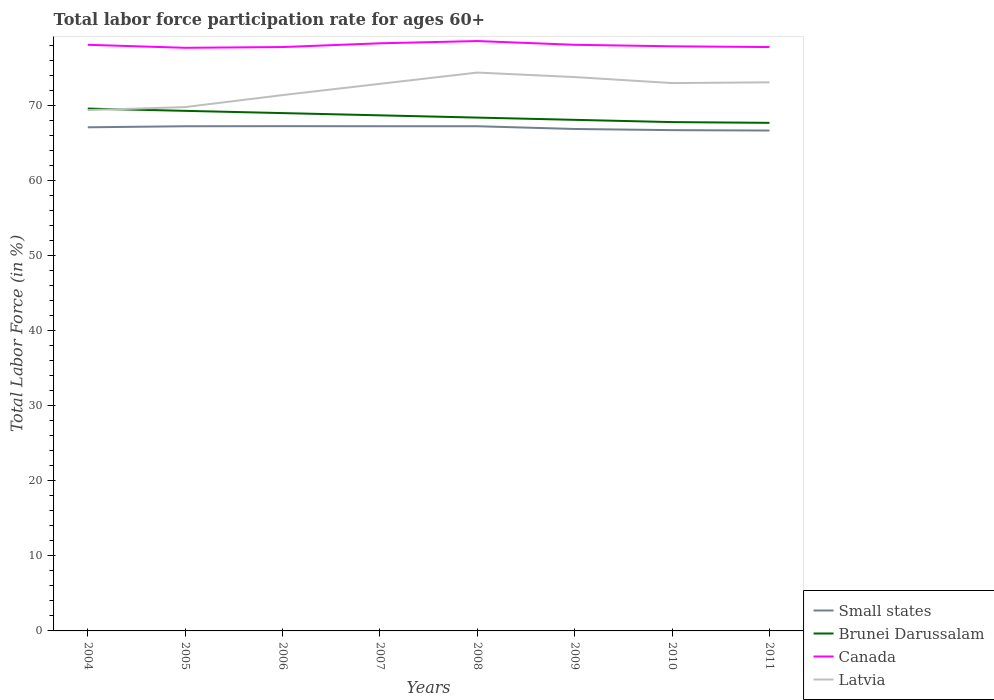How many different coloured lines are there?
Keep it short and to the point. 4. Does the line corresponding to Brunei Darussalam intersect with the line corresponding to Latvia?
Your response must be concise. Yes. Is the number of lines equal to the number of legend labels?
Your response must be concise. Yes. Across all years, what is the maximum labor force participation rate in Canada?
Offer a very short reply. 77.7. In which year was the labor force participation rate in Brunei Darussalam maximum?
Your answer should be compact. 2011. What is the total labor force participation rate in Canada in the graph?
Make the answer very short. 0.1. What is the difference between the highest and the second highest labor force participation rate in Latvia?
Your answer should be very brief. 5. What is the difference between the highest and the lowest labor force participation rate in Latvia?
Your answer should be compact. 5. Is the labor force participation rate in Small states strictly greater than the labor force participation rate in Latvia over the years?
Make the answer very short. Yes. How many lines are there?
Make the answer very short. 4. Are the values on the major ticks of Y-axis written in scientific E-notation?
Your answer should be compact. No. Does the graph contain grids?
Offer a very short reply. No. How many legend labels are there?
Give a very brief answer. 4. How are the legend labels stacked?
Your answer should be very brief. Vertical. What is the title of the graph?
Give a very brief answer. Total labor force participation rate for ages 60+. Does "Puerto Rico" appear as one of the legend labels in the graph?
Ensure brevity in your answer.  No. What is the label or title of the X-axis?
Your response must be concise. Years. What is the Total Labor Force (in %) in Small states in 2004?
Your answer should be very brief. 67.11. What is the Total Labor Force (in %) of Brunei Darussalam in 2004?
Offer a terse response. 69.6. What is the Total Labor Force (in %) of Canada in 2004?
Offer a terse response. 78.1. What is the Total Labor Force (in %) in Latvia in 2004?
Offer a terse response. 69.4. What is the Total Labor Force (in %) in Small states in 2005?
Provide a short and direct response. 67.25. What is the Total Labor Force (in %) in Brunei Darussalam in 2005?
Give a very brief answer. 69.3. What is the Total Labor Force (in %) of Canada in 2005?
Keep it short and to the point. 77.7. What is the Total Labor Force (in %) in Latvia in 2005?
Make the answer very short. 69.8. What is the Total Labor Force (in %) in Small states in 2006?
Your response must be concise. 67.26. What is the Total Labor Force (in %) in Brunei Darussalam in 2006?
Offer a very short reply. 69. What is the Total Labor Force (in %) of Canada in 2006?
Your answer should be compact. 77.8. What is the Total Labor Force (in %) in Latvia in 2006?
Give a very brief answer. 71.4. What is the Total Labor Force (in %) in Small states in 2007?
Provide a succinct answer. 67.25. What is the Total Labor Force (in %) in Brunei Darussalam in 2007?
Your answer should be compact. 68.7. What is the Total Labor Force (in %) of Canada in 2007?
Ensure brevity in your answer.  78.3. What is the Total Labor Force (in %) in Latvia in 2007?
Make the answer very short. 72.9. What is the Total Labor Force (in %) of Small states in 2008?
Keep it short and to the point. 67.25. What is the Total Labor Force (in %) in Brunei Darussalam in 2008?
Ensure brevity in your answer.  68.4. What is the Total Labor Force (in %) in Canada in 2008?
Your answer should be very brief. 78.6. What is the Total Labor Force (in %) of Latvia in 2008?
Your answer should be compact. 74.4. What is the Total Labor Force (in %) in Small states in 2009?
Offer a terse response. 66.88. What is the Total Labor Force (in %) in Brunei Darussalam in 2009?
Keep it short and to the point. 68.1. What is the Total Labor Force (in %) in Canada in 2009?
Provide a short and direct response. 78.1. What is the Total Labor Force (in %) in Latvia in 2009?
Give a very brief answer. 73.8. What is the Total Labor Force (in %) of Small states in 2010?
Make the answer very short. 66.73. What is the Total Labor Force (in %) of Brunei Darussalam in 2010?
Make the answer very short. 67.8. What is the Total Labor Force (in %) in Canada in 2010?
Make the answer very short. 77.9. What is the Total Labor Force (in %) of Small states in 2011?
Offer a very short reply. 66.68. What is the Total Labor Force (in %) in Brunei Darussalam in 2011?
Provide a short and direct response. 67.7. What is the Total Labor Force (in %) of Canada in 2011?
Make the answer very short. 77.8. What is the Total Labor Force (in %) of Latvia in 2011?
Keep it short and to the point. 73.1. Across all years, what is the maximum Total Labor Force (in %) in Small states?
Make the answer very short. 67.26. Across all years, what is the maximum Total Labor Force (in %) in Brunei Darussalam?
Your answer should be very brief. 69.6. Across all years, what is the maximum Total Labor Force (in %) of Canada?
Offer a terse response. 78.6. Across all years, what is the maximum Total Labor Force (in %) of Latvia?
Your response must be concise. 74.4. Across all years, what is the minimum Total Labor Force (in %) in Small states?
Keep it short and to the point. 66.68. Across all years, what is the minimum Total Labor Force (in %) of Brunei Darussalam?
Ensure brevity in your answer.  67.7. Across all years, what is the minimum Total Labor Force (in %) of Canada?
Ensure brevity in your answer.  77.7. Across all years, what is the minimum Total Labor Force (in %) of Latvia?
Ensure brevity in your answer.  69.4. What is the total Total Labor Force (in %) in Small states in the graph?
Provide a succinct answer. 536.4. What is the total Total Labor Force (in %) in Brunei Darussalam in the graph?
Your answer should be very brief. 548.6. What is the total Total Labor Force (in %) in Canada in the graph?
Provide a succinct answer. 624.3. What is the total Total Labor Force (in %) in Latvia in the graph?
Provide a short and direct response. 577.8. What is the difference between the Total Labor Force (in %) in Small states in 2004 and that in 2005?
Your response must be concise. -0.14. What is the difference between the Total Labor Force (in %) in Canada in 2004 and that in 2005?
Keep it short and to the point. 0.4. What is the difference between the Total Labor Force (in %) of Small states in 2004 and that in 2006?
Make the answer very short. -0.15. What is the difference between the Total Labor Force (in %) of Brunei Darussalam in 2004 and that in 2006?
Provide a short and direct response. 0.6. What is the difference between the Total Labor Force (in %) in Latvia in 2004 and that in 2006?
Make the answer very short. -2. What is the difference between the Total Labor Force (in %) of Small states in 2004 and that in 2007?
Keep it short and to the point. -0.14. What is the difference between the Total Labor Force (in %) of Canada in 2004 and that in 2007?
Provide a short and direct response. -0.2. What is the difference between the Total Labor Force (in %) of Small states in 2004 and that in 2008?
Provide a short and direct response. -0.14. What is the difference between the Total Labor Force (in %) of Latvia in 2004 and that in 2008?
Make the answer very short. -5. What is the difference between the Total Labor Force (in %) of Small states in 2004 and that in 2009?
Make the answer very short. 0.22. What is the difference between the Total Labor Force (in %) of Small states in 2004 and that in 2010?
Provide a short and direct response. 0.38. What is the difference between the Total Labor Force (in %) of Brunei Darussalam in 2004 and that in 2010?
Offer a very short reply. 1.8. What is the difference between the Total Labor Force (in %) in Canada in 2004 and that in 2010?
Your answer should be very brief. 0.2. What is the difference between the Total Labor Force (in %) of Latvia in 2004 and that in 2010?
Make the answer very short. -3.6. What is the difference between the Total Labor Force (in %) in Small states in 2004 and that in 2011?
Provide a succinct answer. 0.43. What is the difference between the Total Labor Force (in %) of Canada in 2004 and that in 2011?
Provide a short and direct response. 0.3. What is the difference between the Total Labor Force (in %) of Latvia in 2004 and that in 2011?
Make the answer very short. -3.7. What is the difference between the Total Labor Force (in %) in Small states in 2005 and that in 2006?
Your response must be concise. -0.01. What is the difference between the Total Labor Force (in %) in Brunei Darussalam in 2005 and that in 2006?
Your answer should be very brief. 0.3. What is the difference between the Total Labor Force (in %) in Canada in 2005 and that in 2006?
Offer a terse response. -0.1. What is the difference between the Total Labor Force (in %) in Small states in 2005 and that in 2007?
Keep it short and to the point. -0. What is the difference between the Total Labor Force (in %) of Brunei Darussalam in 2005 and that in 2007?
Keep it short and to the point. 0.6. What is the difference between the Total Labor Force (in %) of Small states in 2005 and that in 2008?
Make the answer very short. -0. What is the difference between the Total Labor Force (in %) of Brunei Darussalam in 2005 and that in 2008?
Make the answer very short. 0.9. What is the difference between the Total Labor Force (in %) in Canada in 2005 and that in 2008?
Provide a succinct answer. -0.9. What is the difference between the Total Labor Force (in %) of Small states in 2005 and that in 2009?
Offer a terse response. 0.36. What is the difference between the Total Labor Force (in %) of Small states in 2005 and that in 2010?
Your response must be concise. 0.52. What is the difference between the Total Labor Force (in %) in Brunei Darussalam in 2005 and that in 2010?
Provide a short and direct response. 1.5. What is the difference between the Total Labor Force (in %) in Canada in 2005 and that in 2010?
Ensure brevity in your answer.  -0.2. What is the difference between the Total Labor Force (in %) in Latvia in 2005 and that in 2010?
Make the answer very short. -3.2. What is the difference between the Total Labor Force (in %) of Small states in 2005 and that in 2011?
Offer a very short reply. 0.57. What is the difference between the Total Labor Force (in %) of Latvia in 2005 and that in 2011?
Your answer should be compact. -3.3. What is the difference between the Total Labor Force (in %) in Small states in 2006 and that in 2007?
Your answer should be compact. 0.01. What is the difference between the Total Labor Force (in %) of Small states in 2006 and that in 2008?
Provide a succinct answer. 0.01. What is the difference between the Total Labor Force (in %) of Brunei Darussalam in 2006 and that in 2008?
Give a very brief answer. 0.6. What is the difference between the Total Labor Force (in %) of Canada in 2006 and that in 2008?
Your response must be concise. -0.8. What is the difference between the Total Labor Force (in %) of Latvia in 2006 and that in 2008?
Make the answer very short. -3. What is the difference between the Total Labor Force (in %) of Small states in 2006 and that in 2009?
Ensure brevity in your answer.  0.38. What is the difference between the Total Labor Force (in %) in Brunei Darussalam in 2006 and that in 2009?
Offer a terse response. 0.9. What is the difference between the Total Labor Force (in %) in Small states in 2006 and that in 2010?
Provide a short and direct response. 0.53. What is the difference between the Total Labor Force (in %) of Brunei Darussalam in 2006 and that in 2010?
Provide a succinct answer. 1.2. What is the difference between the Total Labor Force (in %) of Canada in 2006 and that in 2010?
Your answer should be very brief. -0.1. What is the difference between the Total Labor Force (in %) of Small states in 2006 and that in 2011?
Offer a terse response. 0.58. What is the difference between the Total Labor Force (in %) in Brunei Darussalam in 2006 and that in 2011?
Your answer should be very brief. 1.3. What is the difference between the Total Labor Force (in %) of Canada in 2006 and that in 2011?
Your answer should be very brief. 0. What is the difference between the Total Labor Force (in %) in Brunei Darussalam in 2007 and that in 2008?
Give a very brief answer. 0.3. What is the difference between the Total Labor Force (in %) of Latvia in 2007 and that in 2008?
Your response must be concise. -1.5. What is the difference between the Total Labor Force (in %) of Small states in 2007 and that in 2009?
Offer a terse response. 0.37. What is the difference between the Total Labor Force (in %) in Brunei Darussalam in 2007 and that in 2009?
Make the answer very short. 0.6. What is the difference between the Total Labor Force (in %) in Latvia in 2007 and that in 2009?
Your answer should be compact. -0.9. What is the difference between the Total Labor Force (in %) of Small states in 2007 and that in 2010?
Provide a succinct answer. 0.52. What is the difference between the Total Labor Force (in %) in Brunei Darussalam in 2007 and that in 2010?
Offer a very short reply. 0.9. What is the difference between the Total Labor Force (in %) of Canada in 2007 and that in 2010?
Give a very brief answer. 0.4. What is the difference between the Total Labor Force (in %) in Small states in 2007 and that in 2011?
Ensure brevity in your answer.  0.57. What is the difference between the Total Labor Force (in %) in Brunei Darussalam in 2007 and that in 2011?
Give a very brief answer. 1. What is the difference between the Total Labor Force (in %) of Small states in 2008 and that in 2009?
Your answer should be compact. 0.37. What is the difference between the Total Labor Force (in %) in Latvia in 2008 and that in 2009?
Your answer should be very brief. 0.6. What is the difference between the Total Labor Force (in %) in Small states in 2008 and that in 2010?
Your answer should be compact. 0.52. What is the difference between the Total Labor Force (in %) of Canada in 2008 and that in 2010?
Your answer should be very brief. 0.7. What is the difference between the Total Labor Force (in %) of Small states in 2008 and that in 2011?
Keep it short and to the point. 0.57. What is the difference between the Total Labor Force (in %) of Brunei Darussalam in 2008 and that in 2011?
Give a very brief answer. 0.7. What is the difference between the Total Labor Force (in %) of Small states in 2009 and that in 2010?
Keep it short and to the point. 0.15. What is the difference between the Total Labor Force (in %) in Brunei Darussalam in 2009 and that in 2010?
Ensure brevity in your answer.  0.3. What is the difference between the Total Labor Force (in %) of Latvia in 2009 and that in 2010?
Your answer should be compact. 0.8. What is the difference between the Total Labor Force (in %) of Small states in 2009 and that in 2011?
Keep it short and to the point. 0.21. What is the difference between the Total Labor Force (in %) of Brunei Darussalam in 2009 and that in 2011?
Give a very brief answer. 0.4. What is the difference between the Total Labor Force (in %) in Canada in 2009 and that in 2011?
Ensure brevity in your answer.  0.3. What is the difference between the Total Labor Force (in %) in Small states in 2010 and that in 2011?
Keep it short and to the point. 0.05. What is the difference between the Total Labor Force (in %) of Latvia in 2010 and that in 2011?
Keep it short and to the point. -0.1. What is the difference between the Total Labor Force (in %) of Small states in 2004 and the Total Labor Force (in %) of Brunei Darussalam in 2005?
Ensure brevity in your answer.  -2.19. What is the difference between the Total Labor Force (in %) of Small states in 2004 and the Total Labor Force (in %) of Canada in 2005?
Provide a short and direct response. -10.59. What is the difference between the Total Labor Force (in %) in Small states in 2004 and the Total Labor Force (in %) in Latvia in 2005?
Ensure brevity in your answer.  -2.69. What is the difference between the Total Labor Force (in %) in Brunei Darussalam in 2004 and the Total Labor Force (in %) in Latvia in 2005?
Provide a succinct answer. -0.2. What is the difference between the Total Labor Force (in %) in Canada in 2004 and the Total Labor Force (in %) in Latvia in 2005?
Ensure brevity in your answer.  8.3. What is the difference between the Total Labor Force (in %) of Small states in 2004 and the Total Labor Force (in %) of Brunei Darussalam in 2006?
Ensure brevity in your answer.  -1.89. What is the difference between the Total Labor Force (in %) in Small states in 2004 and the Total Labor Force (in %) in Canada in 2006?
Ensure brevity in your answer.  -10.69. What is the difference between the Total Labor Force (in %) of Small states in 2004 and the Total Labor Force (in %) of Latvia in 2006?
Keep it short and to the point. -4.29. What is the difference between the Total Labor Force (in %) in Canada in 2004 and the Total Labor Force (in %) in Latvia in 2006?
Your answer should be compact. 6.7. What is the difference between the Total Labor Force (in %) in Small states in 2004 and the Total Labor Force (in %) in Brunei Darussalam in 2007?
Your response must be concise. -1.59. What is the difference between the Total Labor Force (in %) of Small states in 2004 and the Total Labor Force (in %) of Canada in 2007?
Give a very brief answer. -11.19. What is the difference between the Total Labor Force (in %) of Small states in 2004 and the Total Labor Force (in %) of Latvia in 2007?
Offer a very short reply. -5.79. What is the difference between the Total Labor Force (in %) of Canada in 2004 and the Total Labor Force (in %) of Latvia in 2007?
Keep it short and to the point. 5.2. What is the difference between the Total Labor Force (in %) of Small states in 2004 and the Total Labor Force (in %) of Brunei Darussalam in 2008?
Provide a short and direct response. -1.29. What is the difference between the Total Labor Force (in %) of Small states in 2004 and the Total Labor Force (in %) of Canada in 2008?
Provide a succinct answer. -11.49. What is the difference between the Total Labor Force (in %) in Small states in 2004 and the Total Labor Force (in %) in Latvia in 2008?
Provide a short and direct response. -7.29. What is the difference between the Total Labor Force (in %) in Small states in 2004 and the Total Labor Force (in %) in Brunei Darussalam in 2009?
Keep it short and to the point. -0.99. What is the difference between the Total Labor Force (in %) of Small states in 2004 and the Total Labor Force (in %) of Canada in 2009?
Keep it short and to the point. -10.99. What is the difference between the Total Labor Force (in %) in Small states in 2004 and the Total Labor Force (in %) in Latvia in 2009?
Provide a succinct answer. -6.69. What is the difference between the Total Labor Force (in %) in Brunei Darussalam in 2004 and the Total Labor Force (in %) in Canada in 2009?
Make the answer very short. -8.5. What is the difference between the Total Labor Force (in %) in Brunei Darussalam in 2004 and the Total Labor Force (in %) in Latvia in 2009?
Your answer should be very brief. -4.2. What is the difference between the Total Labor Force (in %) of Small states in 2004 and the Total Labor Force (in %) of Brunei Darussalam in 2010?
Your answer should be compact. -0.69. What is the difference between the Total Labor Force (in %) in Small states in 2004 and the Total Labor Force (in %) in Canada in 2010?
Provide a succinct answer. -10.79. What is the difference between the Total Labor Force (in %) of Small states in 2004 and the Total Labor Force (in %) of Latvia in 2010?
Your response must be concise. -5.89. What is the difference between the Total Labor Force (in %) of Brunei Darussalam in 2004 and the Total Labor Force (in %) of Canada in 2010?
Offer a terse response. -8.3. What is the difference between the Total Labor Force (in %) of Brunei Darussalam in 2004 and the Total Labor Force (in %) of Latvia in 2010?
Your response must be concise. -3.4. What is the difference between the Total Labor Force (in %) in Small states in 2004 and the Total Labor Force (in %) in Brunei Darussalam in 2011?
Keep it short and to the point. -0.59. What is the difference between the Total Labor Force (in %) of Small states in 2004 and the Total Labor Force (in %) of Canada in 2011?
Keep it short and to the point. -10.69. What is the difference between the Total Labor Force (in %) of Small states in 2004 and the Total Labor Force (in %) of Latvia in 2011?
Ensure brevity in your answer.  -5.99. What is the difference between the Total Labor Force (in %) of Brunei Darussalam in 2004 and the Total Labor Force (in %) of Canada in 2011?
Your answer should be compact. -8.2. What is the difference between the Total Labor Force (in %) of Small states in 2005 and the Total Labor Force (in %) of Brunei Darussalam in 2006?
Ensure brevity in your answer.  -1.75. What is the difference between the Total Labor Force (in %) in Small states in 2005 and the Total Labor Force (in %) in Canada in 2006?
Your answer should be very brief. -10.55. What is the difference between the Total Labor Force (in %) in Small states in 2005 and the Total Labor Force (in %) in Latvia in 2006?
Your answer should be compact. -4.15. What is the difference between the Total Labor Force (in %) of Brunei Darussalam in 2005 and the Total Labor Force (in %) of Canada in 2006?
Ensure brevity in your answer.  -8.5. What is the difference between the Total Labor Force (in %) of Small states in 2005 and the Total Labor Force (in %) of Brunei Darussalam in 2007?
Offer a very short reply. -1.45. What is the difference between the Total Labor Force (in %) of Small states in 2005 and the Total Labor Force (in %) of Canada in 2007?
Make the answer very short. -11.05. What is the difference between the Total Labor Force (in %) of Small states in 2005 and the Total Labor Force (in %) of Latvia in 2007?
Your response must be concise. -5.65. What is the difference between the Total Labor Force (in %) in Brunei Darussalam in 2005 and the Total Labor Force (in %) in Latvia in 2007?
Ensure brevity in your answer.  -3.6. What is the difference between the Total Labor Force (in %) in Small states in 2005 and the Total Labor Force (in %) in Brunei Darussalam in 2008?
Keep it short and to the point. -1.15. What is the difference between the Total Labor Force (in %) of Small states in 2005 and the Total Labor Force (in %) of Canada in 2008?
Make the answer very short. -11.35. What is the difference between the Total Labor Force (in %) of Small states in 2005 and the Total Labor Force (in %) of Latvia in 2008?
Ensure brevity in your answer.  -7.15. What is the difference between the Total Labor Force (in %) in Brunei Darussalam in 2005 and the Total Labor Force (in %) in Canada in 2008?
Your answer should be very brief. -9.3. What is the difference between the Total Labor Force (in %) in Small states in 2005 and the Total Labor Force (in %) in Brunei Darussalam in 2009?
Offer a terse response. -0.85. What is the difference between the Total Labor Force (in %) of Small states in 2005 and the Total Labor Force (in %) of Canada in 2009?
Make the answer very short. -10.85. What is the difference between the Total Labor Force (in %) in Small states in 2005 and the Total Labor Force (in %) in Latvia in 2009?
Your answer should be very brief. -6.55. What is the difference between the Total Labor Force (in %) of Small states in 2005 and the Total Labor Force (in %) of Brunei Darussalam in 2010?
Make the answer very short. -0.55. What is the difference between the Total Labor Force (in %) of Small states in 2005 and the Total Labor Force (in %) of Canada in 2010?
Offer a terse response. -10.65. What is the difference between the Total Labor Force (in %) in Small states in 2005 and the Total Labor Force (in %) in Latvia in 2010?
Keep it short and to the point. -5.75. What is the difference between the Total Labor Force (in %) of Brunei Darussalam in 2005 and the Total Labor Force (in %) of Canada in 2010?
Ensure brevity in your answer.  -8.6. What is the difference between the Total Labor Force (in %) of Brunei Darussalam in 2005 and the Total Labor Force (in %) of Latvia in 2010?
Provide a succinct answer. -3.7. What is the difference between the Total Labor Force (in %) in Small states in 2005 and the Total Labor Force (in %) in Brunei Darussalam in 2011?
Make the answer very short. -0.45. What is the difference between the Total Labor Force (in %) of Small states in 2005 and the Total Labor Force (in %) of Canada in 2011?
Offer a very short reply. -10.55. What is the difference between the Total Labor Force (in %) in Small states in 2005 and the Total Labor Force (in %) in Latvia in 2011?
Make the answer very short. -5.85. What is the difference between the Total Labor Force (in %) in Brunei Darussalam in 2005 and the Total Labor Force (in %) in Canada in 2011?
Ensure brevity in your answer.  -8.5. What is the difference between the Total Labor Force (in %) of Small states in 2006 and the Total Labor Force (in %) of Brunei Darussalam in 2007?
Make the answer very short. -1.44. What is the difference between the Total Labor Force (in %) of Small states in 2006 and the Total Labor Force (in %) of Canada in 2007?
Your answer should be very brief. -11.04. What is the difference between the Total Labor Force (in %) in Small states in 2006 and the Total Labor Force (in %) in Latvia in 2007?
Provide a succinct answer. -5.64. What is the difference between the Total Labor Force (in %) of Brunei Darussalam in 2006 and the Total Labor Force (in %) of Canada in 2007?
Keep it short and to the point. -9.3. What is the difference between the Total Labor Force (in %) of Brunei Darussalam in 2006 and the Total Labor Force (in %) of Latvia in 2007?
Your answer should be compact. -3.9. What is the difference between the Total Labor Force (in %) in Canada in 2006 and the Total Labor Force (in %) in Latvia in 2007?
Provide a succinct answer. 4.9. What is the difference between the Total Labor Force (in %) of Small states in 2006 and the Total Labor Force (in %) of Brunei Darussalam in 2008?
Ensure brevity in your answer.  -1.14. What is the difference between the Total Labor Force (in %) of Small states in 2006 and the Total Labor Force (in %) of Canada in 2008?
Offer a terse response. -11.34. What is the difference between the Total Labor Force (in %) in Small states in 2006 and the Total Labor Force (in %) in Latvia in 2008?
Give a very brief answer. -7.14. What is the difference between the Total Labor Force (in %) of Canada in 2006 and the Total Labor Force (in %) of Latvia in 2008?
Keep it short and to the point. 3.4. What is the difference between the Total Labor Force (in %) in Small states in 2006 and the Total Labor Force (in %) in Brunei Darussalam in 2009?
Keep it short and to the point. -0.84. What is the difference between the Total Labor Force (in %) in Small states in 2006 and the Total Labor Force (in %) in Canada in 2009?
Offer a very short reply. -10.84. What is the difference between the Total Labor Force (in %) of Small states in 2006 and the Total Labor Force (in %) of Latvia in 2009?
Provide a short and direct response. -6.54. What is the difference between the Total Labor Force (in %) of Brunei Darussalam in 2006 and the Total Labor Force (in %) of Latvia in 2009?
Keep it short and to the point. -4.8. What is the difference between the Total Labor Force (in %) of Canada in 2006 and the Total Labor Force (in %) of Latvia in 2009?
Your response must be concise. 4. What is the difference between the Total Labor Force (in %) in Small states in 2006 and the Total Labor Force (in %) in Brunei Darussalam in 2010?
Make the answer very short. -0.54. What is the difference between the Total Labor Force (in %) in Small states in 2006 and the Total Labor Force (in %) in Canada in 2010?
Make the answer very short. -10.64. What is the difference between the Total Labor Force (in %) of Small states in 2006 and the Total Labor Force (in %) of Latvia in 2010?
Offer a very short reply. -5.74. What is the difference between the Total Labor Force (in %) of Brunei Darussalam in 2006 and the Total Labor Force (in %) of Latvia in 2010?
Offer a very short reply. -4. What is the difference between the Total Labor Force (in %) in Small states in 2006 and the Total Labor Force (in %) in Brunei Darussalam in 2011?
Offer a terse response. -0.44. What is the difference between the Total Labor Force (in %) of Small states in 2006 and the Total Labor Force (in %) of Canada in 2011?
Provide a short and direct response. -10.54. What is the difference between the Total Labor Force (in %) of Small states in 2006 and the Total Labor Force (in %) of Latvia in 2011?
Give a very brief answer. -5.84. What is the difference between the Total Labor Force (in %) in Brunei Darussalam in 2006 and the Total Labor Force (in %) in Canada in 2011?
Make the answer very short. -8.8. What is the difference between the Total Labor Force (in %) in Brunei Darussalam in 2006 and the Total Labor Force (in %) in Latvia in 2011?
Give a very brief answer. -4.1. What is the difference between the Total Labor Force (in %) in Canada in 2006 and the Total Labor Force (in %) in Latvia in 2011?
Your answer should be very brief. 4.7. What is the difference between the Total Labor Force (in %) of Small states in 2007 and the Total Labor Force (in %) of Brunei Darussalam in 2008?
Offer a terse response. -1.15. What is the difference between the Total Labor Force (in %) of Small states in 2007 and the Total Labor Force (in %) of Canada in 2008?
Provide a short and direct response. -11.35. What is the difference between the Total Labor Force (in %) of Small states in 2007 and the Total Labor Force (in %) of Latvia in 2008?
Your response must be concise. -7.15. What is the difference between the Total Labor Force (in %) in Brunei Darussalam in 2007 and the Total Labor Force (in %) in Canada in 2008?
Keep it short and to the point. -9.9. What is the difference between the Total Labor Force (in %) of Small states in 2007 and the Total Labor Force (in %) of Brunei Darussalam in 2009?
Make the answer very short. -0.85. What is the difference between the Total Labor Force (in %) in Small states in 2007 and the Total Labor Force (in %) in Canada in 2009?
Make the answer very short. -10.85. What is the difference between the Total Labor Force (in %) of Small states in 2007 and the Total Labor Force (in %) of Latvia in 2009?
Provide a short and direct response. -6.55. What is the difference between the Total Labor Force (in %) in Brunei Darussalam in 2007 and the Total Labor Force (in %) in Latvia in 2009?
Keep it short and to the point. -5.1. What is the difference between the Total Labor Force (in %) of Canada in 2007 and the Total Labor Force (in %) of Latvia in 2009?
Provide a short and direct response. 4.5. What is the difference between the Total Labor Force (in %) of Small states in 2007 and the Total Labor Force (in %) of Brunei Darussalam in 2010?
Your answer should be very brief. -0.55. What is the difference between the Total Labor Force (in %) of Small states in 2007 and the Total Labor Force (in %) of Canada in 2010?
Provide a succinct answer. -10.65. What is the difference between the Total Labor Force (in %) of Small states in 2007 and the Total Labor Force (in %) of Latvia in 2010?
Provide a short and direct response. -5.75. What is the difference between the Total Labor Force (in %) of Canada in 2007 and the Total Labor Force (in %) of Latvia in 2010?
Keep it short and to the point. 5.3. What is the difference between the Total Labor Force (in %) in Small states in 2007 and the Total Labor Force (in %) in Brunei Darussalam in 2011?
Make the answer very short. -0.45. What is the difference between the Total Labor Force (in %) in Small states in 2007 and the Total Labor Force (in %) in Canada in 2011?
Make the answer very short. -10.55. What is the difference between the Total Labor Force (in %) in Small states in 2007 and the Total Labor Force (in %) in Latvia in 2011?
Provide a short and direct response. -5.85. What is the difference between the Total Labor Force (in %) in Brunei Darussalam in 2007 and the Total Labor Force (in %) in Canada in 2011?
Offer a terse response. -9.1. What is the difference between the Total Labor Force (in %) of Brunei Darussalam in 2007 and the Total Labor Force (in %) of Latvia in 2011?
Make the answer very short. -4.4. What is the difference between the Total Labor Force (in %) of Canada in 2007 and the Total Labor Force (in %) of Latvia in 2011?
Provide a succinct answer. 5.2. What is the difference between the Total Labor Force (in %) in Small states in 2008 and the Total Labor Force (in %) in Brunei Darussalam in 2009?
Provide a short and direct response. -0.85. What is the difference between the Total Labor Force (in %) of Small states in 2008 and the Total Labor Force (in %) of Canada in 2009?
Your answer should be very brief. -10.85. What is the difference between the Total Labor Force (in %) in Small states in 2008 and the Total Labor Force (in %) in Latvia in 2009?
Provide a short and direct response. -6.55. What is the difference between the Total Labor Force (in %) in Brunei Darussalam in 2008 and the Total Labor Force (in %) in Canada in 2009?
Offer a very short reply. -9.7. What is the difference between the Total Labor Force (in %) of Canada in 2008 and the Total Labor Force (in %) of Latvia in 2009?
Your answer should be very brief. 4.8. What is the difference between the Total Labor Force (in %) of Small states in 2008 and the Total Labor Force (in %) of Brunei Darussalam in 2010?
Ensure brevity in your answer.  -0.55. What is the difference between the Total Labor Force (in %) in Small states in 2008 and the Total Labor Force (in %) in Canada in 2010?
Provide a succinct answer. -10.65. What is the difference between the Total Labor Force (in %) in Small states in 2008 and the Total Labor Force (in %) in Latvia in 2010?
Your response must be concise. -5.75. What is the difference between the Total Labor Force (in %) of Brunei Darussalam in 2008 and the Total Labor Force (in %) of Latvia in 2010?
Offer a terse response. -4.6. What is the difference between the Total Labor Force (in %) of Small states in 2008 and the Total Labor Force (in %) of Brunei Darussalam in 2011?
Offer a very short reply. -0.45. What is the difference between the Total Labor Force (in %) of Small states in 2008 and the Total Labor Force (in %) of Canada in 2011?
Keep it short and to the point. -10.55. What is the difference between the Total Labor Force (in %) in Small states in 2008 and the Total Labor Force (in %) in Latvia in 2011?
Offer a very short reply. -5.85. What is the difference between the Total Labor Force (in %) in Canada in 2008 and the Total Labor Force (in %) in Latvia in 2011?
Your response must be concise. 5.5. What is the difference between the Total Labor Force (in %) of Small states in 2009 and the Total Labor Force (in %) of Brunei Darussalam in 2010?
Ensure brevity in your answer.  -0.92. What is the difference between the Total Labor Force (in %) of Small states in 2009 and the Total Labor Force (in %) of Canada in 2010?
Give a very brief answer. -11.02. What is the difference between the Total Labor Force (in %) in Small states in 2009 and the Total Labor Force (in %) in Latvia in 2010?
Your response must be concise. -6.12. What is the difference between the Total Labor Force (in %) of Canada in 2009 and the Total Labor Force (in %) of Latvia in 2010?
Your response must be concise. 5.1. What is the difference between the Total Labor Force (in %) of Small states in 2009 and the Total Labor Force (in %) of Brunei Darussalam in 2011?
Offer a terse response. -0.82. What is the difference between the Total Labor Force (in %) of Small states in 2009 and the Total Labor Force (in %) of Canada in 2011?
Ensure brevity in your answer.  -10.92. What is the difference between the Total Labor Force (in %) in Small states in 2009 and the Total Labor Force (in %) in Latvia in 2011?
Ensure brevity in your answer.  -6.22. What is the difference between the Total Labor Force (in %) in Canada in 2009 and the Total Labor Force (in %) in Latvia in 2011?
Make the answer very short. 5. What is the difference between the Total Labor Force (in %) of Small states in 2010 and the Total Labor Force (in %) of Brunei Darussalam in 2011?
Your answer should be very brief. -0.97. What is the difference between the Total Labor Force (in %) in Small states in 2010 and the Total Labor Force (in %) in Canada in 2011?
Your answer should be very brief. -11.07. What is the difference between the Total Labor Force (in %) of Small states in 2010 and the Total Labor Force (in %) of Latvia in 2011?
Keep it short and to the point. -6.37. What is the difference between the Total Labor Force (in %) in Brunei Darussalam in 2010 and the Total Labor Force (in %) in Latvia in 2011?
Provide a short and direct response. -5.3. What is the difference between the Total Labor Force (in %) in Canada in 2010 and the Total Labor Force (in %) in Latvia in 2011?
Keep it short and to the point. 4.8. What is the average Total Labor Force (in %) of Small states per year?
Keep it short and to the point. 67.05. What is the average Total Labor Force (in %) of Brunei Darussalam per year?
Ensure brevity in your answer.  68.58. What is the average Total Labor Force (in %) of Canada per year?
Your answer should be very brief. 78.04. What is the average Total Labor Force (in %) of Latvia per year?
Offer a terse response. 72.22. In the year 2004, what is the difference between the Total Labor Force (in %) in Small states and Total Labor Force (in %) in Brunei Darussalam?
Provide a short and direct response. -2.49. In the year 2004, what is the difference between the Total Labor Force (in %) in Small states and Total Labor Force (in %) in Canada?
Your response must be concise. -10.99. In the year 2004, what is the difference between the Total Labor Force (in %) of Small states and Total Labor Force (in %) of Latvia?
Ensure brevity in your answer.  -2.29. In the year 2004, what is the difference between the Total Labor Force (in %) of Brunei Darussalam and Total Labor Force (in %) of Canada?
Your answer should be compact. -8.5. In the year 2004, what is the difference between the Total Labor Force (in %) of Brunei Darussalam and Total Labor Force (in %) of Latvia?
Your response must be concise. 0.2. In the year 2005, what is the difference between the Total Labor Force (in %) of Small states and Total Labor Force (in %) of Brunei Darussalam?
Your answer should be very brief. -2.05. In the year 2005, what is the difference between the Total Labor Force (in %) in Small states and Total Labor Force (in %) in Canada?
Provide a short and direct response. -10.45. In the year 2005, what is the difference between the Total Labor Force (in %) in Small states and Total Labor Force (in %) in Latvia?
Provide a short and direct response. -2.55. In the year 2006, what is the difference between the Total Labor Force (in %) in Small states and Total Labor Force (in %) in Brunei Darussalam?
Ensure brevity in your answer.  -1.74. In the year 2006, what is the difference between the Total Labor Force (in %) of Small states and Total Labor Force (in %) of Canada?
Provide a succinct answer. -10.54. In the year 2006, what is the difference between the Total Labor Force (in %) in Small states and Total Labor Force (in %) in Latvia?
Your answer should be compact. -4.14. In the year 2006, what is the difference between the Total Labor Force (in %) in Brunei Darussalam and Total Labor Force (in %) in Canada?
Your answer should be compact. -8.8. In the year 2006, what is the difference between the Total Labor Force (in %) in Canada and Total Labor Force (in %) in Latvia?
Keep it short and to the point. 6.4. In the year 2007, what is the difference between the Total Labor Force (in %) of Small states and Total Labor Force (in %) of Brunei Darussalam?
Your answer should be very brief. -1.45. In the year 2007, what is the difference between the Total Labor Force (in %) in Small states and Total Labor Force (in %) in Canada?
Your answer should be very brief. -11.05. In the year 2007, what is the difference between the Total Labor Force (in %) of Small states and Total Labor Force (in %) of Latvia?
Ensure brevity in your answer.  -5.65. In the year 2007, what is the difference between the Total Labor Force (in %) of Canada and Total Labor Force (in %) of Latvia?
Ensure brevity in your answer.  5.4. In the year 2008, what is the difference between the Total Labor Force (in %) of Small states and Total Labor Force (in %) of Brunei Darussalam?
Your response must be concise. -1.15. In the year 2008, what is the difference between the Total Labor Force (in %) in Small states and Total Labor Force (in %) in Canada?
Offer a very short reply. -11.35. In the year 2008, what is the difference between the Total Labor Force (in %) in Small states and Total Labor Force (in %) in Latvia?
Your answer should be compact. -7.15. In the year 2008, what is the difference between the Total Labor Force (in %) in Brunei Darussalam and Total Labor Force (in %) in Canada?
Provide a succinct answer. -10.2. In the year 2009, what is the difference between the Total Labor Force (in %) in Small states and Total Labor Force (in %) in Brunei Darussalam?
Your response must be concise. -1.22. In the year 2009, what is the difference between the Total Labor Force (in %) of Small states and Total Labor Force (in %) of Canada?
Ensure brevity in your answer.  -11.22. In the year 2009, what is the difference between the Total Labor Force (in %) in Small states and Total Labor Force (in %) in Latvia?
Your answer should be compact. -6.92. In the year 2009, what is the difference between the Total Labor Force (in %) of Brunei Darussalam and Total Labor Force (in %) of Canada?
Your answer should be compact. -10. In the year 2009, what is the difference between the Total Labor Force (in %) in Canada and Total Labor Force (in %) in Latvia?
Provide a short and direct response. 4.3. In the year 2010, what is the difference between the Total Labor Force (in %) in Small states and Total Labor Force (in %) in Brunei Darussalam?
Give a very brief answer. -1.07. In the year 2010, what is the difference between the Total Labor Force (in %) of Small states and Total Labor Force (in %) of Canada?
Your answer should be very brief. -11.17. In the year 2010, what is the difference between the Total Labor Force (in %) of Small states and Total Labor Force (in %) of Latvia?
Your answer should be compact. -6.27. In the year 2010, what is the difference between the Total Labor Force (in %) of Brunei Darussalam and Total Labor Force (in %) of Latvia?
Keep it short and to the point. -5.2. In the year 2011, what is the difference between the Total Labor Force (in %) of Small states and Total Labor Force (in %) of Brunei Darussalam?
Your response must be concise. -1.02. In the year 2011, what is the difference between the Total Labor Force (in %) of Small states and Total Labor Force (in %) of Canada?
Offer a terse response. -11.12. In the year 2011, what is the difference between the Total Labor Force (in %) in Small states and Total Labor Force (in %) in Latvia?
Make the answer very short. -6.42. In the year 2011, what is the difference between the Total Labor Force (in %) of Brunei Darussalam and Total Labor Force (in %) of Canada?
Your answer should be compact. -10.1. In the year 2011, what is the difference between the Total Labor Force (in %) in Brunei Darussalam and Total Labor Force (in %) in Latvia?
Ensure brevity in your answer.  -5.4. In the year 2011, what is the difference between the Total Labor Force (in %) in Canada and Total Labor Force (in %) in Latvia?
Offer a very short reply. 4.7. What is the ratio of the Total Labor Force (in %) of Brunei Darussalam in 2004 to that in 2005?
Give a very brief answer. 1. What is the ratio of the Total Labor Force (in %) of Canada in 2004 to that in 2005?
Ensure brevity in your answer.  1.01. What is the ratio of the Total Labor Force (in %) of Small states in 2004 to that in 2006?
Your answer should be very brief. 1. What is the ratio of the Total Labor Force (in %) in Brunei Darussalam in 2004 to that in 2006?
Make the answer very short. 1.01. What is the ratio of the Total Labor Force (in %) of Brunei Darussalam in 2004 to that in 2007?
Offer a terse response. 1.01. What is the ratio of the Total Labor Force (in %) in Brunei Darussalam in 2004 to that in 2008?
Your answer should be very brief. 1.02. What is the ratio of the Total Labor Force (in %) of Canada in 2004 to that in 2008?
Your response must be concise. 0.99. What is the ratio of the Total Labor Force (in %) of Latvia in 2004 to that in 2008?
Make the answer very short. 0.93. What is the ratio of the Total Labor Force (in %) of Small states in 2004 to that in 2009?
Your response must be concise. 1. What is the ratio of the Total Labor Force (in %) of Latvia in 2004 to that in 2009?
Provide a short and direct response. 0.94. What is the ratio of the Total Labor Force (in %) of Brunei Darussalam in 2004 to that in 2010?
Offer a terse response. 1.03. What is the ratio of the Total Labor Force (in %) of Canada in 2004 to that in 2010?
Give a very brief answer. 1. What is the ratio of the Total Labor Force (in %) of Latvia in 2004 to that in 2010?
Provide a short and direct response. 0.95. What is the ratio of the Total Labor Force (in %) of Small states in 2004 to that in 2011?
Ensure brevity in your answer.  1.01. What is the ratio of the Total Labor Force (in %) of Brunei Darussalam in 2004 to that in 2011?
Offer a terse response. 1.03. What is the ratio of the Total Labor Force (in %) of Latvia in 2004 to that in 2011?
Give a very brief answer. 0.95. What is the ratio of the Total Labor Force (in %) of Brunei Darussalam in 2005 to that in 2006?
Keep it short and to the point. 1. What is the ratio of the Total Labor Force (in %) of Canada in 2005 to that in 2006?
Offer a terse response. 1. What is the ratio of the Total Labor Force (in %) in Latvia in 2005 to that in 2006?
Provide a short and direct response. 0.98. What is the ratio of the Total Labor Force (in %) in Brunei Darussalam in 2005 to that in 2007?
Offer a very short reply. 1.01. What is the ratio of the Total Labor Force (in %) in Latvia in 2005 to that in 2007?
Your answer should be compact. 0.96. What is the ratio of the Total Labor Force (in %) in Small states in 2005 to that in 2008?
Your answer should be very brief. 1. What is the ratio of the Total Labor Force (in %) of Brunei Darussalam in 2005 to that in 2008?
Your answer should be very brief. 1.01. What is the ratio of the Total Labor Force (in %) of Canada in 2005 to that in 2008?
Your answer should be very brief. 0.99. What is the ratio of the Total Labor Force (in %) in Latvia in 2005 to that in 2008?
Your answer should be compact. 0.94. What is the ratio of the Total Labor Force (in %) of Small states in 2005 to that in 2009?
Ensure brevity in your answer.  1.01. What is the ratio of the Total Labor Force (in %) of Brunei Darussalam in 2005 to that in 2009?
Give a very brief answer. 1.02. What is the ratio of the Total Labor Force (in %) in Latvia in 2005 to that in 2009?
Keep it short and to the point. 0.95. What is the ratio of the Total Labor Force (in %) of Brunei Darussalam in 2005 to that in 2010?
Offer a very short reply. 1.02. What is the ratio of the Total Labor Force (in %) in Canada in 2005 to that in 2010?
Your answer should be compact. 1. What is the ratio of the Total Labor Force (in %) in Latvia in 2005 to that in 2010?
Ensure brevity in your answer.  0.96. What is the ratio of the Total Labor Force (in %) in Small states in 2005 to that in 2011?
Provide a succinct answer. 1.01. What is the ratio of the Total Labor Force (in %) in Brunei Darussalam in 2005 to that in 2011?
Give a very brief answer. 1.02. What is the ratio of the Total Labor Force (in %) of Canada in 2005 to that in 2011?
Your answer should be compact. 1. What is the ratio of the Total Labor Force (in %) of Latvia in 2005 to that in 2011?
Keep it short and to the point. 0.95. What is the ratio of the Total Labor Force (in %) in Small states in 2006 to that in 2007?
Provide a succinct answer. 1. What is the ratio of the Total Labor Force (in %) of Canada in 2006 to that in 2007?
Ensure brevity in your answer.  0.99. What is the ratio of the Total Labor Force (in %) in Latvia in 2006 to that in 2007?
Keep it short and to the point. 0.98. What is the ratio of the Total Labor Force (in %) in Brunei Darussalam in 2006 to that in 2008?
Your answer should be very brief. 1.01. What is the ratio of the Total Labor Force (in %) of Latvia in 2006 to that in 2008?
Ensure brevity in your answer.  0.96. What is the ratio of the Total Labor Force (in %) in Small states in 2006 to that in 2009?
Provide a succinct answer. 1.01. What is the ratio of the Total Labor Force (in %) of Brunei Darussalam in 2006 to that in 2009?
Offer a very short reply. 1.01. What is the ratio of the Total Labor Force (in %) of Latvia in 2006 to that in 2009?
Provide a short and direct response. 0.97. What is the ratio of the Total Labor Force (in %) of Small states in 2006 to that in 2010?
Offer a terse response. 1.01. What is the ratio of the Total Labor Force (in %) in Brunei Darussalam in 2006 to that in 2010?
Offer a terse response. 1.02. What is the ratio of the Total Labor Force (in %) in Latvia in 2006 to that in 2010?
Give a very brief answer. 0.98. What is the ratio of the Total Labor Force (in %) of Small states in 2006 to that in 2011?
Provide a succinct answer. 1.01. What is the ratio of the Total Labor Force (in %) in Brunei Darussalam in 2006 to that in 2011?
Your response must be concise. 1.02. What is the ratio of the Total Labor Force (in %) of Canada in 2006 to that in 2011?
Your response must be concise. 1. What is the ratio of the Total Labor Force (in %) of Latvia in 2006 to that in 2011?
Offer a very short reply. 0.98. What is the ratio of the Total Labor Force (in %) of Brunei Darussalam in 2007 to that in 2008?
Provide a succinct answer. 1. What is the ratio of the Total Labor Force (in %) of Latvia in 2007 to that in 2008?
Make the answer very short. 0.98. What is the ratio of the Total Labor Force (in %) in Small states in 2007 to that in 2009?
Give a very brief answer. 1.01. What is the ratio of the Total Labor Force (in %) of Brunei Darussalam in 2007 to that in 2009?
Provide a succinct answer. 1.01. What is the ratio of the Total Labor Force (in %) of Latvia in 2007 to that in 2009?
Provide a short and direct response. 0.99. What is the ratio of the Total Labor Force (in %) in Small states in 2007 to that in 2010?
Your answer should be very brief. 1.01. What is the ratio of the Total Labor Force (in %) in Brunei Darussalam in 2007 to that in 2010?
Provide a short and direct response. 1.01. What is the ratio of the Total Labor Force (in %) in Latvia in 2007 to that in 2010?
Provide a succinct answer. 1. What is the ratio of the Total Labor Force (in %) of Small states in 2007 to that in 2011?
Your answer should be compact. 1.01. What is the ratio of the Total Labor Force (in %) in Brunei Darussalam in 2007 to that in 2011?
Provide a short and direct response. 1.01. What is the ratio of the Total Labor Force (in %) in Canada in 2007 to that in 2011?
Keep it short and to the point. 1.01. What is the ratio of the Total Labor Force (in %) in Small states in 2008 to that in 2009?
Provide a succinct answer. 1.01. What is the ratio of the Total Labor Force (in %) of Canada in 2008 to that in 2009?
Keep it short and to the point. 1.01. What is the ratio of the Total Labor Force (in %) of Small states in 2008 to that in 2010?
Offer a terse response. 1.01. What is the ratio of the Total Labor Force (in %) in Brunei Darussalam in 2008 to that in 2010?
Your answer should be compact. 1.01. What is the ratio of the Total Labor Force (in %) of Canada in 2008 to that in 2010?
Your answer should be compact. 1.01. What is the ratio of the Total Labor Force (in %) of Latvia in 2008 to that in 2010?
Make the answer very short. 1.02. What is the ratio of the Total Labor Force (in %) in Small states in 2008 to that in 2011?
Your response must be concise. 1.01. What is the ratio of the Total Labor Force (in %) in Brunei Darussalam in 2008 to that in 2011?
Ensure brevity in your answer.  1.01. What is the ratio of the Total Labor Force (in %) in Canada in 2008 to that in 2011?
Provide a short and direct response. 1.01. What is the ratio of the Total Labor Force (in %) of Latvia in 2008 to that in 2011?
Ensure brevity in your answer.  1.02. What is the ratio of the Total Labor Force (in %) of Small states in 2009 to that in 2010?
Provide a short and direct response. 1. What is the ratio of the Total Labor Force (in %) in Brunei Darussalam in 2009 to that in 2010?
Provide a succinct answer. 1. What is the ratio of the Total Labor Force (in %) in Canada in 2009 to that in 2010?
Make the answer very short. 1. What is the ratio of the Total Labor Force (in %) in Brunei Darussalam in 2009 to that in 2011?
Provide a succinct answer. 1.01. What is the ratio of the Total Labor Force (in %) in Canada in 2009 to that in 2011?
Give a very brief answer. 1. What is the ratio of the Total Labor Force (in %) in Latvia in 2009 to that in 2011?
Your answer should be very brief. 1.01. What is the ratio of the Total Labor Force (in %) of Brunei Darussalam in 2010 to that in 2011?
Provide a short and direct response. 1. What is the difference between the highest and the second highest Total Labor Force (in %) in Small states?
Ensure brevity in your answer.  0.01. What is the difference between the highest and the second highest Total Labor Force (in %) of Brunei Darussalam?
Offer a very short reply. 0.3. What is the difference between the highest and the second highest Total Labor Force (in %) of Canada?
Give a very brief answer. 0.3. What is the difference between the highest and the second highest Total Labor Force (in %) of Latvia?
Keep it short and to the point. 0.6. What is the difference between the highest and the lowest Total Labor Force (in %) in Small states?
Your response must be concise. 0.58. What is the difference between the highest and the lowest Total Labor Force (in %) in Brunei Darussalam?
Make the answer very short. 1.9. 